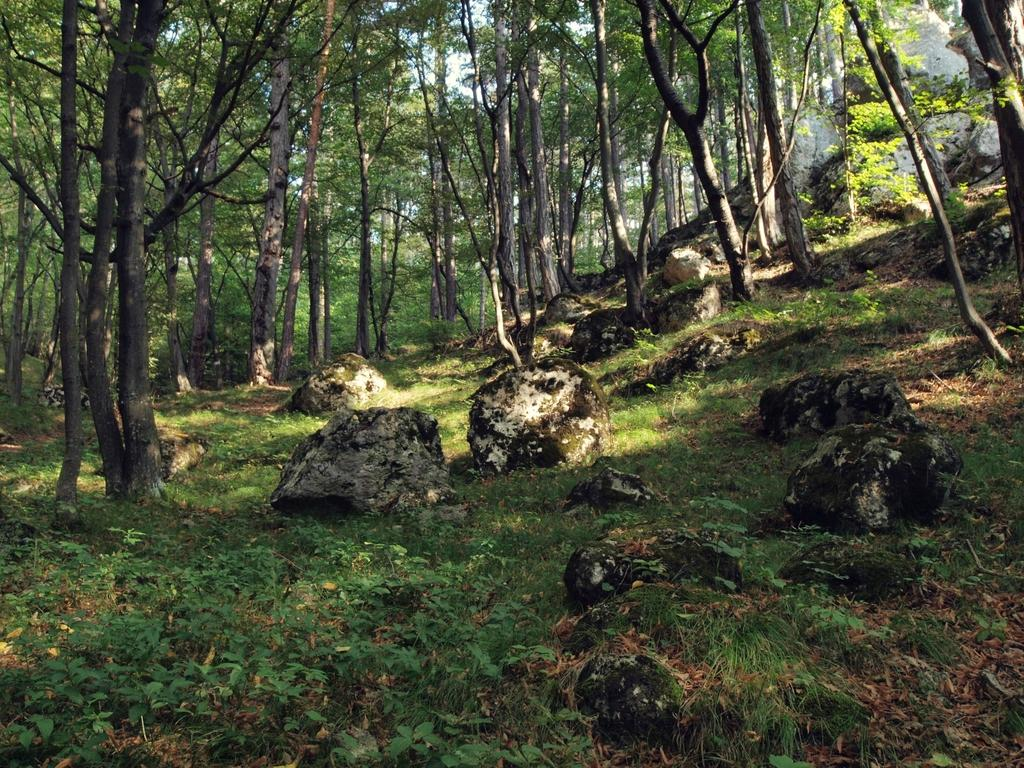What is present at the bottom of the picture? There are herbs and rocks at the bottom of the picture. What can be seen in the background of the image? There are trees in the background of the image. What type of environment might the image depict? The image might have been taken in a forest. How much sugar is present in the rocks in the image? There is no sugar present in the rocks in the image. Can you see any bubbles floating around the trees in the background? There are no bubbles present in the image. 